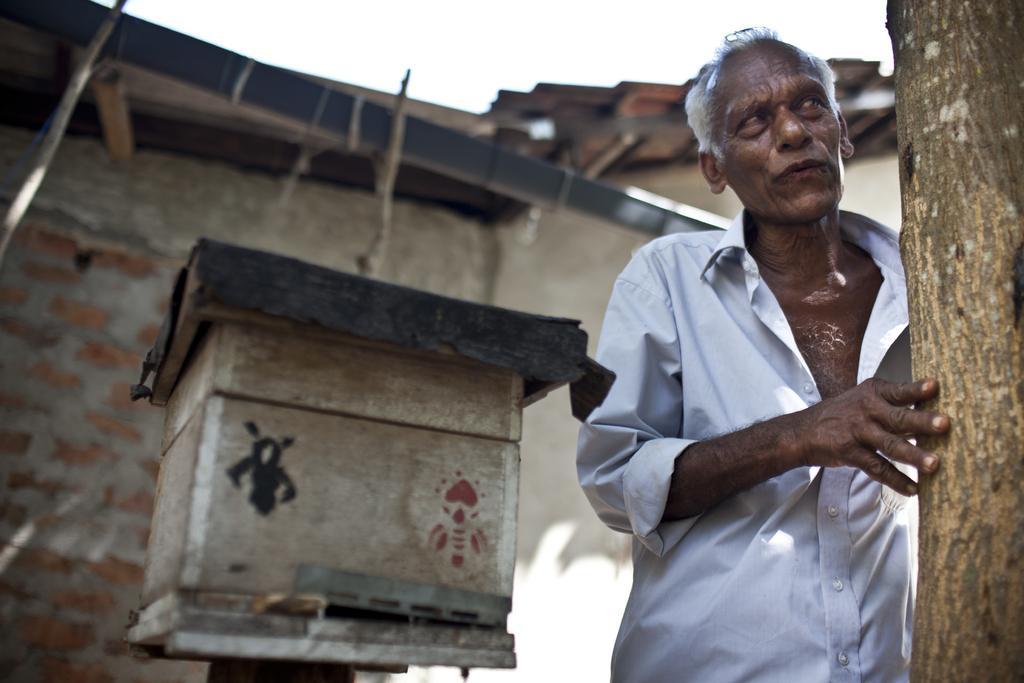Please provide a concise description of this image. In this image, on the right side, we can see a wooden trunk, we can also see a man holding a wooden trunk. In the middle of the image, we can see a wood box. In the background, we can see a house, brick wall and wood sticks. At the top, we can see a sky. 